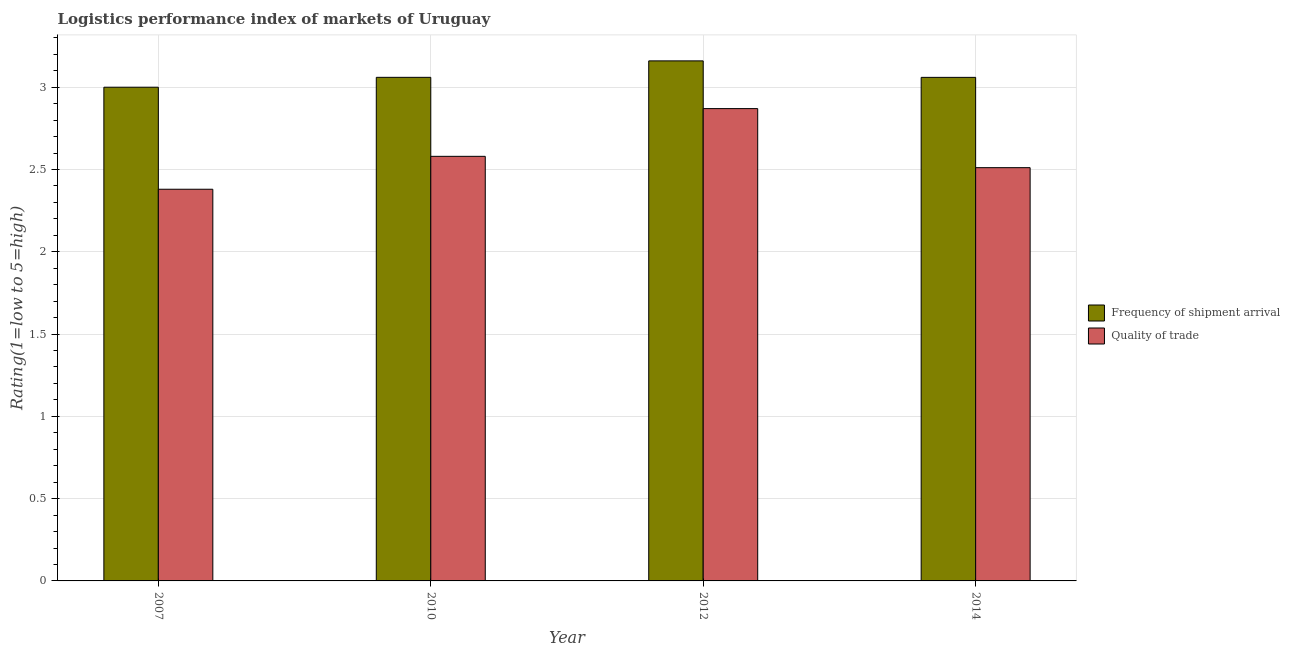How many groups of bars are there?
Offer a terse response. 4. Are the number of bars per tick equal to the number of legend labels?
Offer a very short reply. Yes. What is the lpi of frequency of shipment arrival in 2012?
Your answer should be compact. 3.16. Across all years, what is the maximum lpi quality of trade?
Your response must be concise. 2.87. Across all years, what is the minimum lpi quality of trade?
Your response must be concise. 2.38. In which year was the lpi quality of trade maximum?
Your answer should be very brief. 2012. What is the total lpi of frequency of shipment arrival in the graph?
Offer a very short reply. 12.28. What is the difference between the lpi quality of trade in 2007 and that in 2010?
Provide a succinct answer. -0.2. What is the difference between the lpi of frequency of shipment arrival in 2010 and the lpi quality of trade in 2007?
Provide a short and direct response. 0.06. What is the average lpi of frequency of shipment arrival per year?
Ensure brevity in your answer.  3.07. In the year 2010, what is the difference between the lpi of frequency of shipment arrival and lpi quality of trade?
Offer a terse response. 0. What is the ratio of the lpi of frequency of shipment arrival in 2007 to that in 2012?
Provide a succinct answer. 0.95. What is the difference between the highest and the second highest lpi of frequency of shipment arrival?
Provide a short and direct response. 0.1. What is the difference between the highest and the lowest lpi of frequency of shipment arrival?
Give a very brief answer. 0.16. What does the 2nd bar from the left in 2014 represents?
Offer a very short reply. Quality of trade. What does the 2nd bar from the right in 2007 represents?
Offer a very short reply. Frequency of shipment arrival. How many bars are there?
Offer a terse response. 8. Are all the bars in the graph horizontal?
Make the answer very short. No. What is the difference between two consecutive major ticks on the Y-axis?
Provide a short and direct response. 0.5. How many legend labels are there?
Ensure brevity in your answer.  2. What is the title of the graph?
Make the answer very short. Logistics performance index of markets of Uruguay. What is the label or title of the Y-axis?
Make the answer very short. Rating(1=low to 5=high). What is the Rating(1=low to 5=high) in Quality of trade in 2007?
Ensure brevity in your answer.  2.38. What is the Rating(1=low to 5=high) of Frequency of shipment arrival in 2010?
Provide a succinct answer. 3.06. What is the Rating(1=low to 5=high) in Quality of trade in 2010?
Your answer should be very brief. 2.58. What is the Rating(1=low to 5=high) in Frequency of shipment arrival in 2012?
Offer a very short reply. 3.16. What is the Rating(1=low to 5=high) of Quality of trade in 2012?
Provide a short and direct response. 2.87. What is the Rating(1=low to 5=high) of Frequency of shipment arrival in 2014?
Offer a very short reply. 3.06. What is the Rating(1=low to 5=high) in Quality of trade in 2014?
Provide a succinct answer. 2.51. Across all years, what is the maximum Rating(1=low to 5=high) of Frequency of shipment arrival?
Your response must be concise. 3.16. Across all years, what is the maximum Rating(1=low to 5=high) of Quality of trade?
Your answer should be very brief. 2.87. Across all years, what is the minimum Rating(1=low to 5=high) in Quality of trade?
Offer a very short reply. 2.38. What is the total Rating(1=low to 5=high) of Frequency of shipment arrival in the graph?
Provide a short and direct response. 12.28. What is the total Rating(1=low to 5=high) in Quality of trade in the graph?
Give a very brief answer. 10.34. What is the difference between the Rating(1=low to 5=high) in Frequency of shipment arrival in 2007 and that in 2010?
Your answer should be very brief. -0.06. What is the difference between the Rating(1=low to 5=high) of Quality of trade in 2007 and that in 2010?
Your response must be concise. -0.2. What is the difference between the Rating(1=low to 5=high) in Frequency of shipment arrival in 2007 and that in 2012?
Your answer should be compact. -0.16. What is the difference between the Rating(1=low to 5=high) of Quality of trade in 2007 and that in 2012?
Provide a short and direct response. -0.49. What is the difference between the Rating(1=low to 5=high) of Frequency of shipment arrival in 2007 and that in 2014?
Keep it short and to the point. -0.06. What is the difference between the Rating(1=low to 5=high) in Quality of trade in 2007 and that in 2014?
Give a very brief answer. -0.13. What is the difference between the Rating(1=low to 5=high) of Frequency of shipment arrival in 2010 and that in 2012?
Offer a very short reply. -0.1. What is the difference between the Rating(1=low to 5=high) of Quality of trade in 2010 and that in 2012?
Give a very brief answer. -0.29. What is the difference between the Rating(1=low to 5=high) in Quality of trade in 2010 and that in 2014?
Your answer should be very brief. 0.07. What is the difference between the Rating(1=low to 5=high) of Frequency of shipment arrival in 2012 and that in 2014?
Give a very brief answer. 0.1. What is the difference between the Rating(1=low to 5=high) of Quality of trade in 2012 and that in 2014?
Make the answer very short. 0.36. What is the difference between the Rating(1=low to 5=high) in Frequency of shipment arrival in 2007 and the Rating(1=low to 5=high) in Quality of trade in 2010?
Ensure brevity in your answer.  0.42. What is the difference between the Rating(1=low to 5=high) in Frequency of shipment arrival in 2007 and the Rating(1=low to 5=high) in Quality of trade in 2012?
Make the answer very short. 0.13. What is the difference between the Rating(1=low to 5=high) of Frequency of shipment arrival in 2007 and the Rating(1=low to 5=high) of Quality of trade in 2014?
Your response must be concise. 0.49. What is the difference between the Rating(1=low to 5=high) of Frequency of shipment arrival in 2010 and the Rating(1=low to 5=high) of Quality of trade in 2012?
Your answer should be very brief. 0.19. What is the difference between the Rating(1=low to 5=high) in Frequency of shipment arrival in 2010 and the Rating(1=low to 5=high) in Quality of trade in 2014?
Ensure brevity in your answer.  0.55. What is the difference between the Rating(1=low to 5=high) of Frequency of shipment arrival in 2012 and the Rating(1=low to 5=high) of Quality of trade in 2014?
Ensure brevity in your answer.  0.65. What is the average Rating(1=low to 5=high) in Frequency of shipment arrival per year?
Provide a short and direct response. 3.07. What is the average Rating(1=low to 5=high) of Quality of trade per year?
Ensure brevity in your answer.  2.59. In the year 2007, what is the difference between the Rating(1=low to 5=high) of Frequency of shipment arrival and Rating(1=low to 5=high) of Quality of trade?
Your answer should be very brief. 0.62. In the year 2010, what is the difference between the Rating(1=low to 5=high) in Frequency of shipment arrival and Rating(1=low to 5=high) in Quality of trade?
Keep it short and to the point. 0.48. In the year 2012, what is the difference between the Rating(1=low to 5=high) in Frequency of shipment arrival and Rating(1=low to 5=high) in Quality of trade?
Offer a terse response. 0.29. In the year 2014, what is the difference between the Rating(1=low to 5=high) of Frequency of shipment arrival and Rating(1=low to 5=high) of Quality of trade?
Ensure brevity in your answer.  0.55. What is the ratio of the Rating(1=low to 5=high) of Frequency of shipment arrival in 2007 to that in 2010?
Give a very brief answer. 0.98. What is the ratio of the Rating(1=low to 5=high) in Quality of trade in 2007 to that in 2010?
Make the answer very short. 0.92. What is the ratio of the Rating(1=low to 5=high) of Frequency of shipment arrival in 2007 to that in 2012?
Make the answer very short. 0.95. What is the ratio of the Rating(1=low to 5=high) of Quality of trade in 2007 to that in 2012?
Ensure brevity in your answer.  0.83. What is the ratio of the Rating(1=low to 5=high) in Frequency of shipment arrival in 2007 to that in 2014?
Offer a very short reply. 0.98. What is the ratio of the Rating(1=low to 5=high) of Quality of trade in 2007 to that in 2014?
Offer a terse response. 0.95. What is the ratio of the Rating(1=low to 5=high) of Frequency of shipment arrival in 2010 to that in 2012?
Keep it short and to the point. 0.97. What is the ratio of the Rating(1=low to 5=high) of Quality of trade in 2010 to that in 2012?
Provide a short and direct response. 0.9. What is the ratio of the Rating(1=low to 5=high) of Frequency of shipment arrival in 2010 to that in 2014?
Your answer should be very brief. 1. What is the ratio of the Rating(1=low to 5=high) in Quality of trade in 2010 to that in 2014?
Provide a short and direct response. 1.03. What is the ratio of the Rating(1=low to 5=high) in Frequency of shipment arrival in 2012 to that in 2014?
Give a very brief answer. 1.03. What is the difference between the highest and the second highest Rating(1=low to 5=high) of Frequency of shipment arrival?
Make the answer very short. 0.1. What is the difference between the highest and the second highest Rating(1=low to 5=high) of Quality of trade?
Keep it short and to the point. 0.29. What is the difference between the highest and the lowest Rating(1=low to 5=high) in Frequency of shipment arrival?
Make the answer very short. 0.16. What is the difference between the highest and the lowest Rating(1=low to 5=high) of Quality of trade?
Keep it short and to the point. 0.49. 